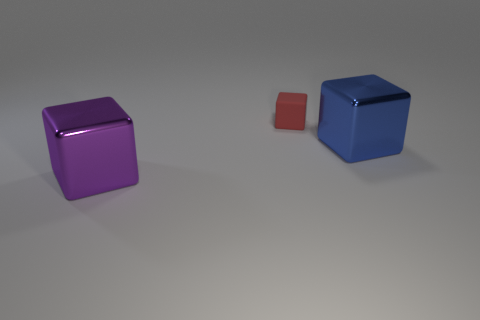Can you estimate the sizes of the cubes relative to each other? In this image, the purple and blue cubes seem to be of a similar size; however, the red cube is visibly smaller. Without exact measurements, it's challenging to provide precise dimensions, but the larger cubes may be roughly twice the size of the smaller red cube. If these cubes were to represent data, what could they signify? Interpreted as a data visualization, the cubes could represent different quantities or values. For instance, they might symbolize financial data where the purple and blue cubes represent equal revenues from two different products, while the smaller red cube shows lesser revenue from a third product. 